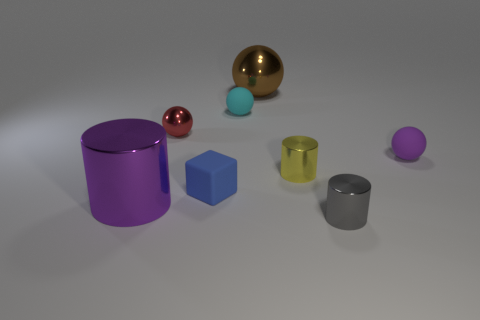Subtract 1 spheres. How many spheres are left? 3 Add 1 big brown metal spheres. How many objects exist? 9 Subtract all cylinders. How many objects are left? 5 Subtract 0 blue cylinders. How many objects are left? 8 Subtract all cylinders. Subtract all red metal spheres. How many objects are left? 4 Add 5 yellow things. How many yellow things are left? 6 Add 8 tiny gray objects. How many tiny gray objects exist? 9 